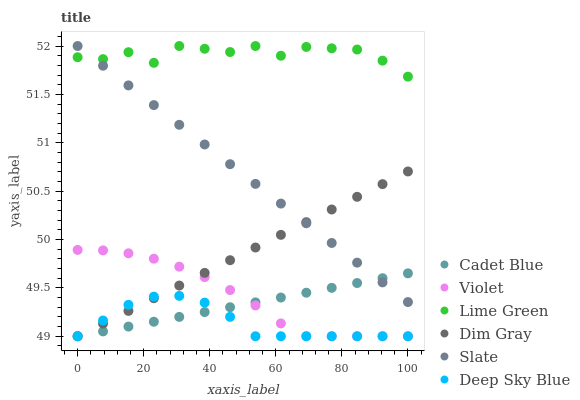Does Deep Sky Blue have the minimum area under the curve?
Answer yes or no. Yes. Does Lime Green have the maximum area under the curve?
Answer yes or no. Yes. Does Slate have the minimum area under the curve?
Answer yes or no. No. Does Slate have the maximum area under the curve?
Answer yes or no. No. Is Cadet Blue the smoothest?
Answer yes or no. Yes. Is Lime Green the roughest?
Answer yes or no. Yes. Is Slate the smoothest?
Answer yes or no. No. Is Slate the roughest?
Answer yes or no. No. Does Dim Gray have the lowest value?
Answer yes or no. Yes. Does Slate have the lowest value?
Answer yes or no. No. Does Lime Green have the highest value?
Answer yes or no. Yes. Does Cadet Blue have the highest value?
Answer yes or no. No. Is Dim Gray less than Lime Green?
Answer yes or no. Yes. Is Lime Green greater than Deep Sky Blue?
Answer yes or no. Yes. Does Deep Sky Blue intersect Cadet Blue?
Answer yes or no. Yes. Is Deep Sky Blue less than Cadet Blue?
Answer yes or no. No. Is Deep Sky Blue greater than Cadet Blue?
Answer yes or no. No. Does Dim Gray intersect Lime Green?
Answer yes or no. No. 